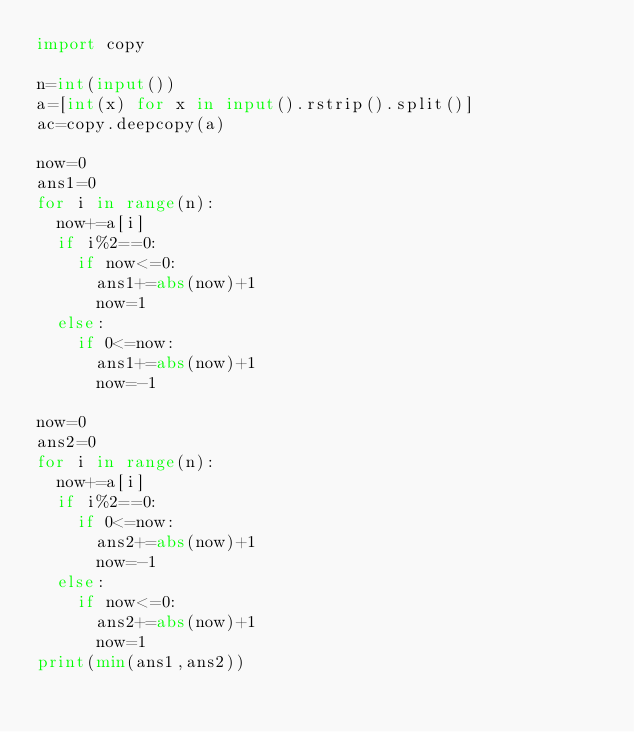Convert code to text. <code><loc_0><loc_0><loc_500><loc_500><_Python_>import copy

n=int(input())
a=[int(x) for x in input().rstrip().split()]
ac=copy.deepcopy(a)

now=0
ans1=0
for i in range(n):
  now+=a[i]
  if i%2==0:
    if now<=0:
      ans1+=abs(now)+1
      now=1
  else:
    if 0<=now:
      ans1+=abs(now)+1
      now=-1

now=0
ans2=0
for i in range(n):
  now+=a[i]
  if i%2==0:
    if 0<=now:
      ans2+=abs(now)+1
      now=-1
  else:
    if now<=0:
      ans2+=abs(now)+1
      now=1
print(min(ans1,ans2))</code> 